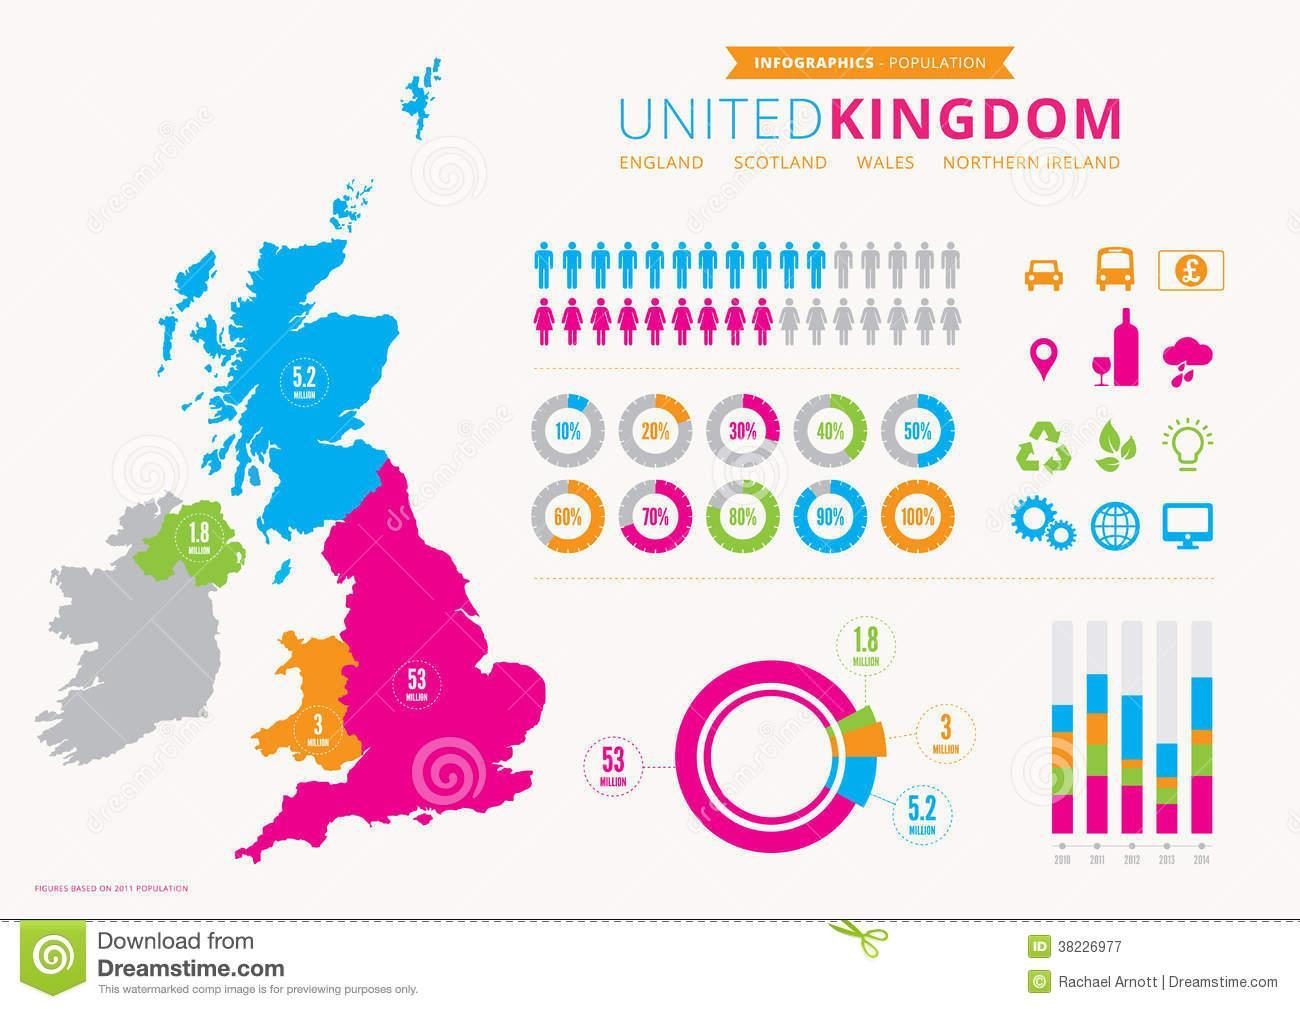Which country has population of 1.8 million?
Answer the question with a short phrase. Northern Ireand Which country has the highest population in 2011? England Which country has population of 5.2 million? Scotland What is the population of Wales? 3 million What is the population of England? 53 million Which country has the second largest population among the 4 countries? Scotland Which country has the least population in 2012? Wales 